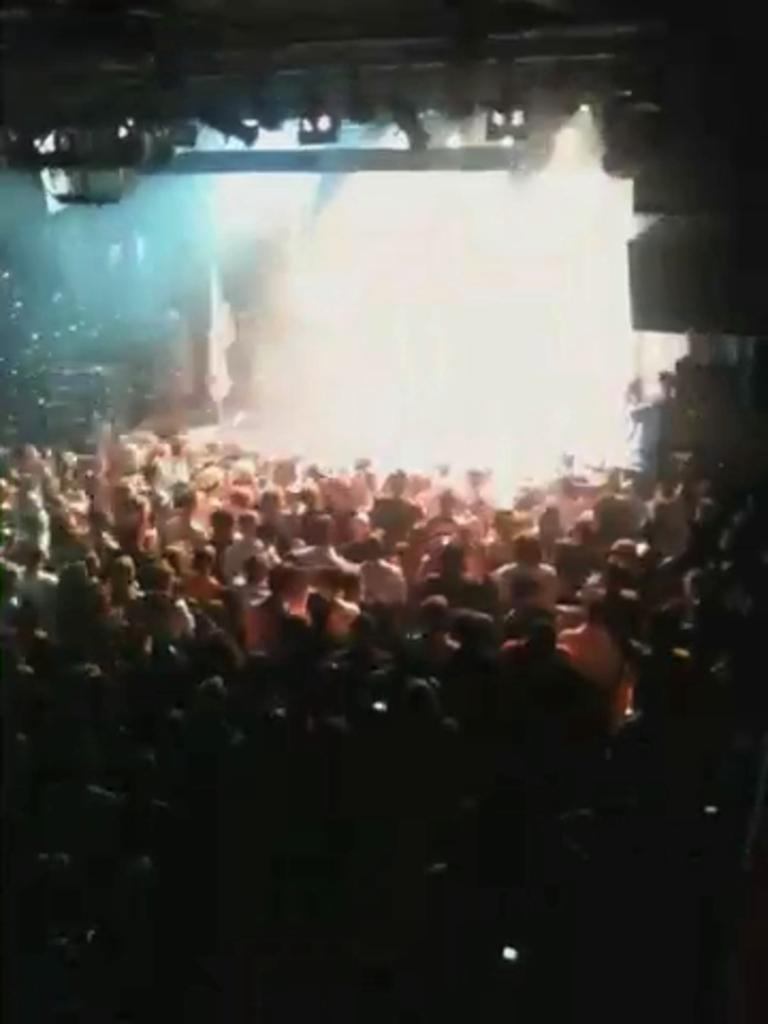Who or what can be seen in the image? There are people in the image. Where does the scene appear to take place? The setting appears to be a hall. What activity might be happening in the image? The scene resembles a concert. What type of tramp can be seen in the image? There is no tramp present in the image. What color is the stem of the flower in the image? There is no flower or stem present in the image. 